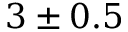<formula> <loc_0><loc_0><loc_500><loc_500>3 \pm 0 . 5</formula> 